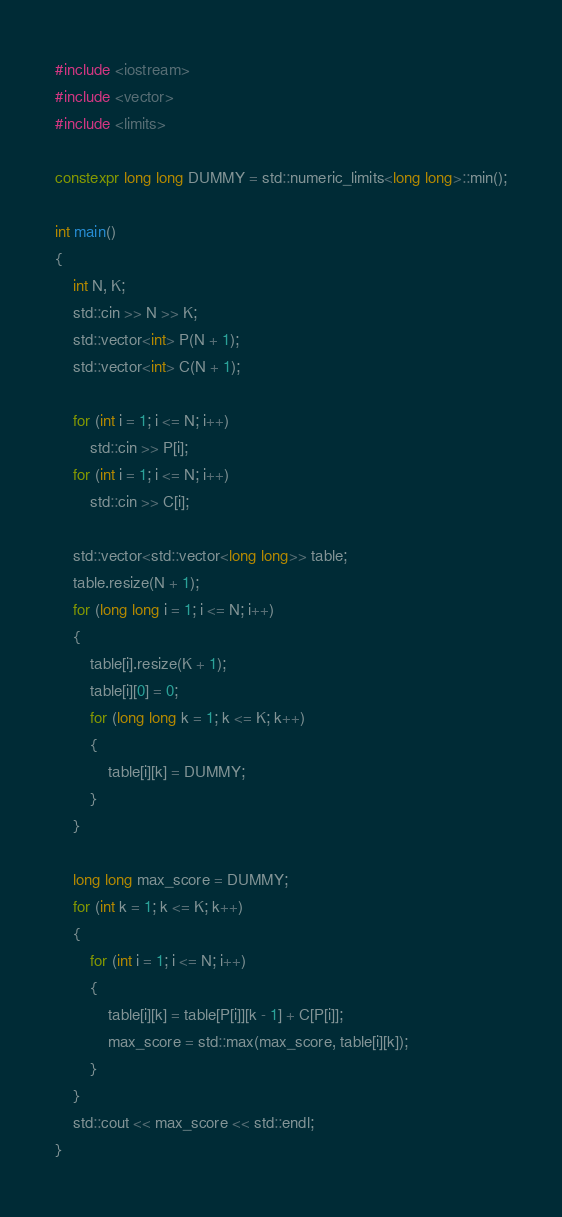<code> <loc_0><loc_0><loc_500><loc_500><_C++_>#include <iostream>
#include <vector>
#include <limits>

constexpr long long DUMMY = std::numeric_limits<long long>::min();

int main()
{
    int N, K;
    std::cin >> N >> K;
    std::vector<int> P(N + 1);
    std::vector<int> C(N + 1);

    for (int i = 1; i <= N; i++)
        std::cin >> P[i];
    for (int i = 1; i <= N; i++)
        std::cin >> C[i];

    std::vector<std::vector<long long>> table;
    table.resize(N + 1);
    for (long long i = 1; i <= N; i++)
    {
        table[i].resize(K + 1);
        table[i][0] = 0;
        for (long long k = 1; k <= K; k++)
        {
            table[i][k] = DUMMY;
        }
    }

    long long max_score = DUMMY;
    for (int k = 1; k <= K; k++)
    {
        for (int i = 1; i <= N; i++)
        {
            table[i][k] = table[P[i]][k - 1] + C[P[i]];
            max_score = std::max(max_score, table[i][k]);
        }
    }
    std::cout << max_score << std::endl;
}</code> 